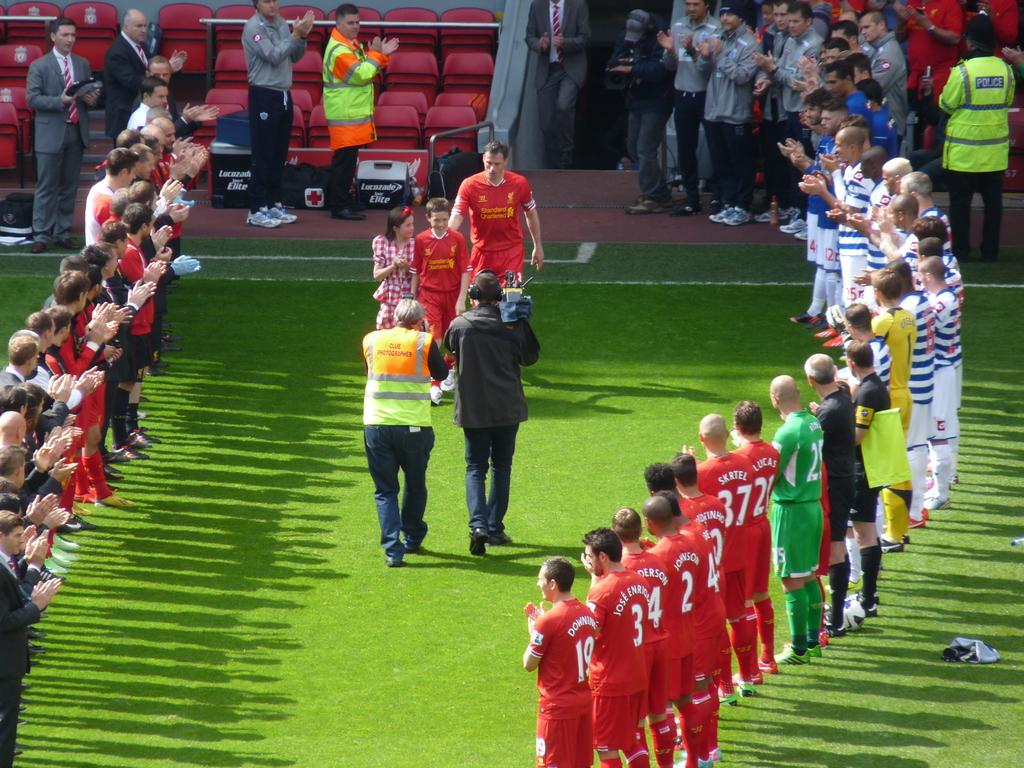<image>
Create a compact narrative representing the image presented. the number 3 that is on the back of a jersey 